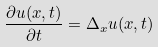Convert formula to latex. <formula><loc_0><loc_0><loc_500><loc_500>\frac { \partial u ( x , t ) } { \partial t } = \Delta _ { x } u ( x , t )</formula> 